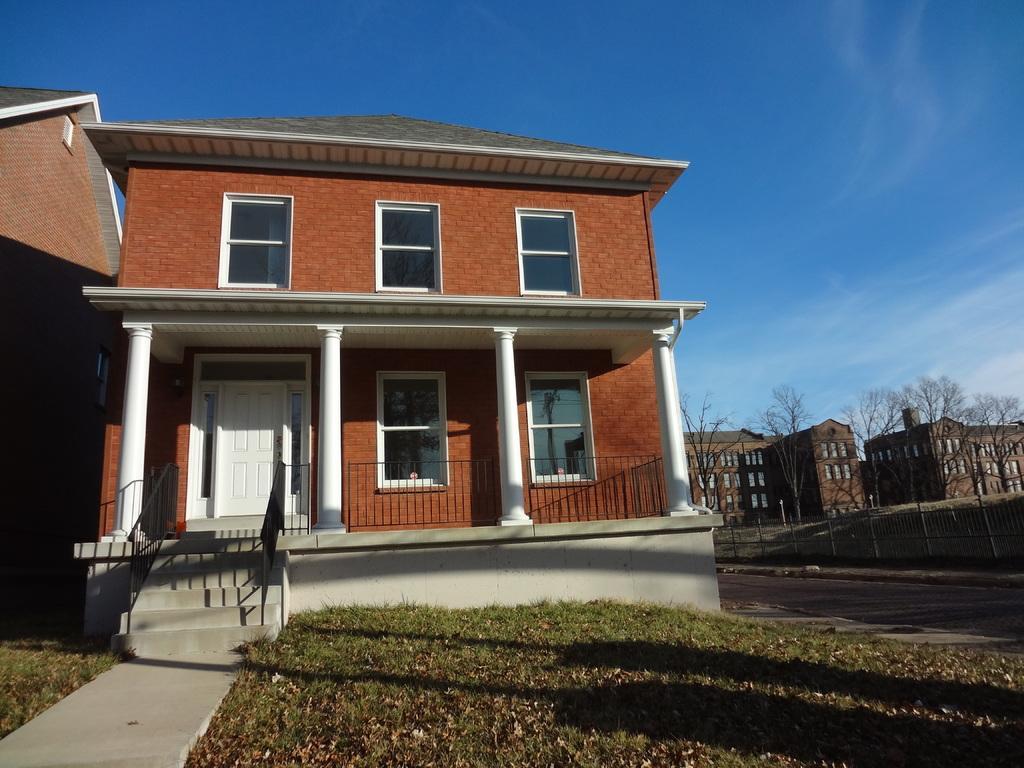Please provide a concise description of this image. In this image we can see a group of buildings with windows, pillars and roof. In the foreground we can see staircase, grass. On the right side of the image we can see a group of trees. In the background, we can see the cloudy sky. 